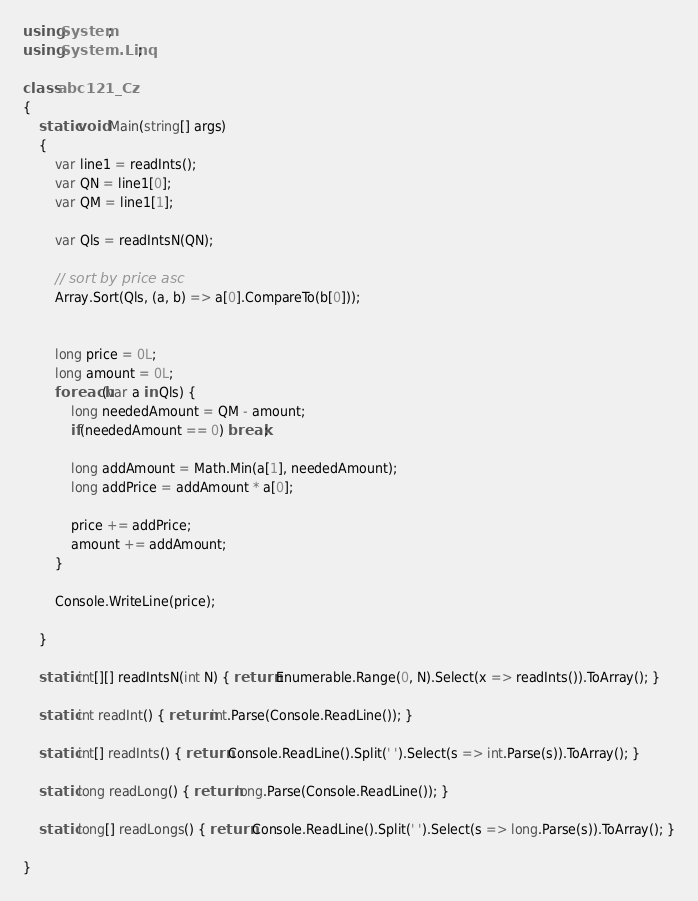<code> <loc_0><loc_0><loc_500><loc_500><_C#_>using System;
using System.Linq;

class abc121_Cz
{
    static void Main(string[] args)
    {
        var line1 = readInts();
        var QN = line1[0];
        var QM = line1[1];

        var Qls = readIntsN(QN);

        // sort by price asc
        Array.Sort(Qls, (a, b) => a[0].CompareTo(b[0]));
        

        long price = 0L;
        long amount = 0L;
        foreach(var a in Qls) {
            long neededAmount = QM - amount;
            if(neededAmount == 0) break;

            long addAmount = Math.Min(a[1], neededAmount);
            long addPrice = addAmount * a[0];

            price += addPrice;
            amount += addAmount;
        }

        Console.WriteLine(price);

    }

    static int[][] readIntsN(int N) { return Enumerable.Range(0, N).Select(x => readInts()).ToArray(); }
    
    static int readInt() { return int.Parse(Console.ReadLine()); }

    static int[] readInts() { return Console.ReadLine().Split(' ').Select(s => int.Parse(s)).ToArray(); }

    static long readLong() { return long.Parse(Console.ReadLine()); }

    static long[] readLongs() { return Console.ReadLine().Split(' ').Select(s => long.Parse(s)).ToArray(); }

}</code> 